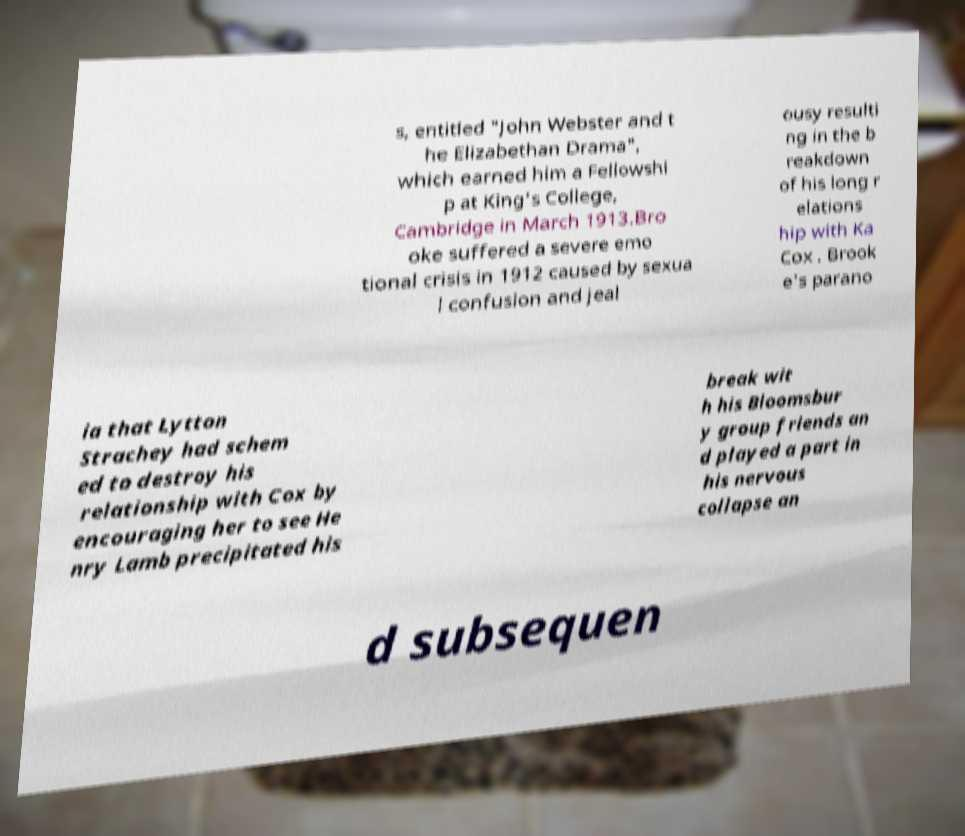I need the written content from this picture converted into text. Can you do that? s, entitled "John Webster and t he Elizabethan Drama", which earned him a Fellowshi p at King's College, Cambridge in March 1913.Bro oke suffered a severe emo tional crisis in 1912 caused by sexua l confusion and jeal ousy resulti ng in the b reakdown of his long r elations hip with Ka Cox . Brook e's parano ia that Lytton Strachey had schem ed to destroy his relationship with Cox by encouraging her to see He nry Lamb precipitated his break wit h his Bloomsbur y group friends an d played a part in his nervous collapse an d subsequen 